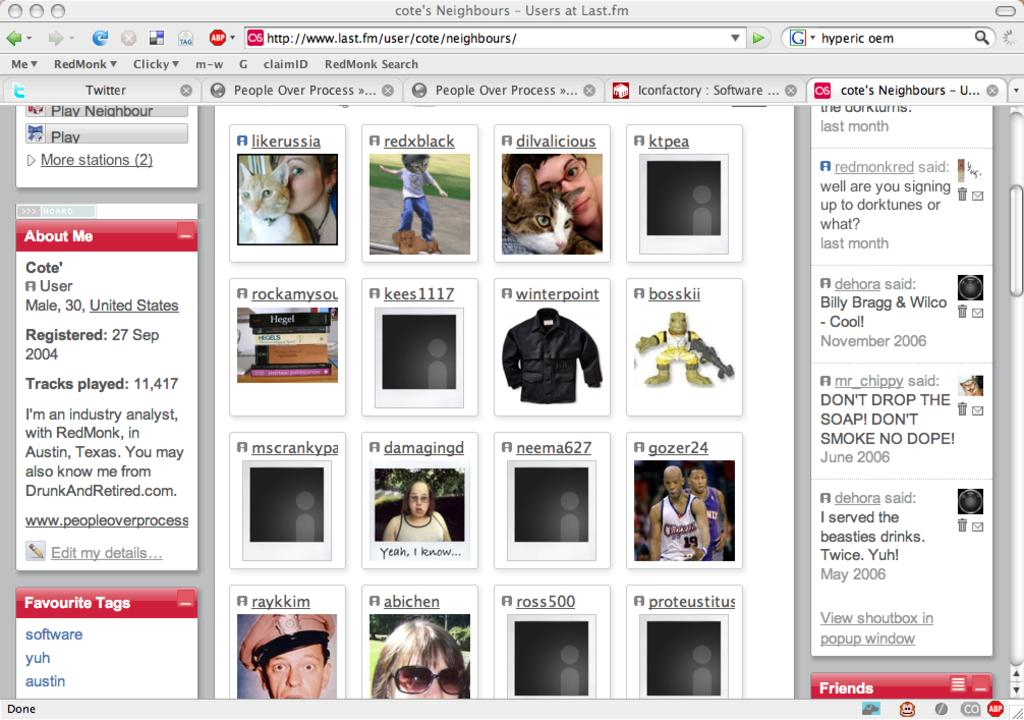What is the main subject of the image? The main subject of the image is a web page. What types of content can be found on the web page? The web page contains pictures and text. What type of oil is being advertised on the web page? There is no advertisement or mention of oil on the web page. How many stalks of celery are depicted in the images on the web page? There are no images of celery on the web page. 